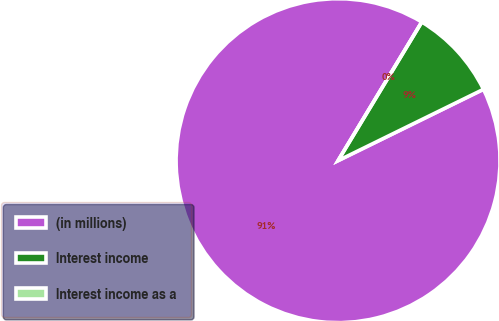<chart> <loc_0><loc_0><loc_500><loc_500><pie_chart><fcel>(in millions)<fcel>Interest income<fcel>Interest income as a<nl><fcel>90.9%<fcel>9.09%<fcel>0.0%<nl></chart> 